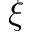<formula> <loc_0><loc_0><loc_500><loc_500>\xi</formula> 